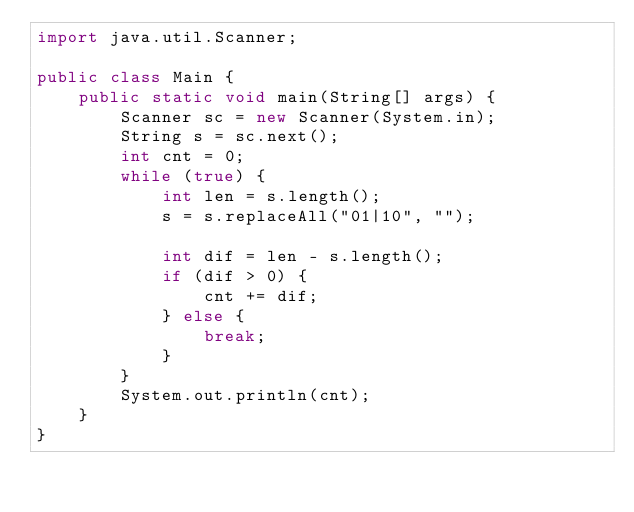<code> <loc_0><loc_0><loc_500><loc_500><_Java_>import java.util.Scanner;

public class Main {
	public static void main(String[] args) {
		Scanner sc = new Scanner(System.in);
		String s = sc.next();
		int cnt = 0;
		while (true) {
			int len = s.length();
			s = s.replaceAll("01|10", "");
			
			int dif = len - s.length();
			if (dif > 0) {
				cnt += dif;
			} else {
				break;
			}
		}
		System.out.println(cnt);
	}
}
</code> 